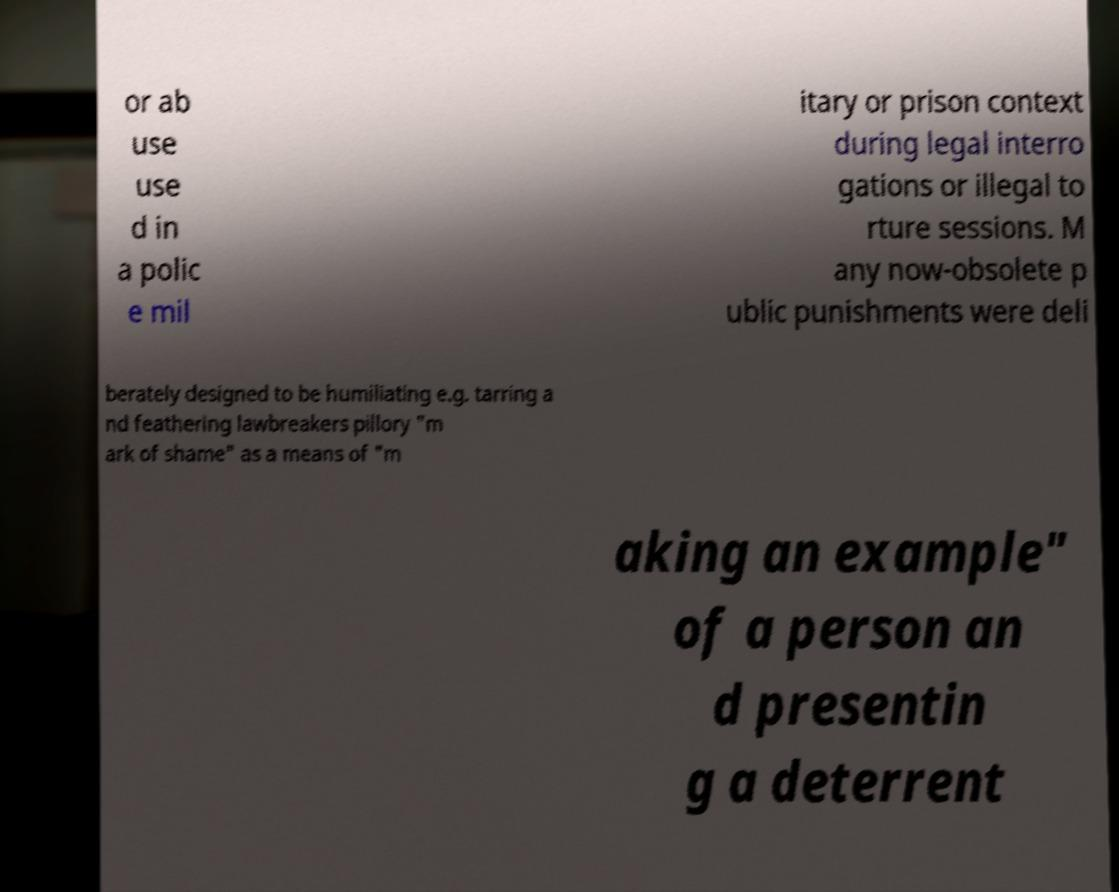Could you extract and type out the text from this image? or ab use use d in a polic e mil itary or prison context during legal interro gations or illegal to rture sessions. M any now-obsolete p ublic punishments were deli berately designed to be humiliating e.g. tarring a nd feathering lawbreakers pillory "m ark of shame" as a means of "m aking an example" of a person an d presentin g a deterrent 